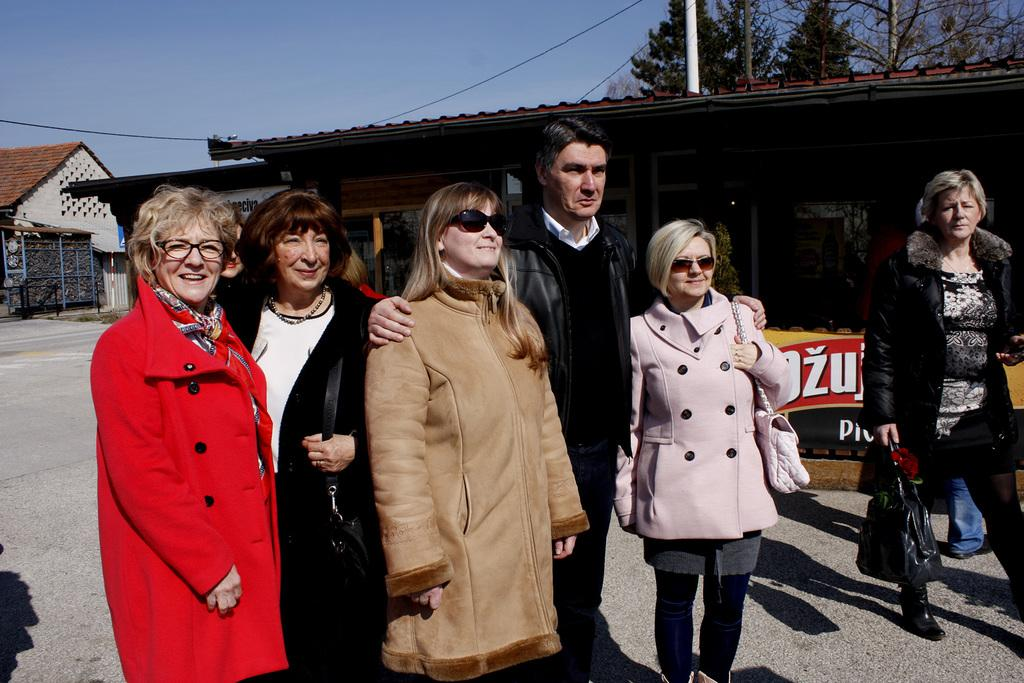How many people are in the image? There is a group of people standing in the image, but the exact number cannot be determined from the provided facts. What type of structures can be seen in the image? There are buildings in the image. What other natural elements are present in the image? There are trees in the image. What else can be seen in the image besides people, buildings, and trees? There are other objects in the image, but their specific nature cannot be determined from the provided facts. What is visible in the background of the image? The sky is visible in the background of the image. What type of quiver is being used by the person in the image? There is no mention of a quiver or any person using one in the image. Can you describe the intricate details of the buildings in the image? The provided facts do not mention any specific details about the buildings, so we cannot describe them in detail. 